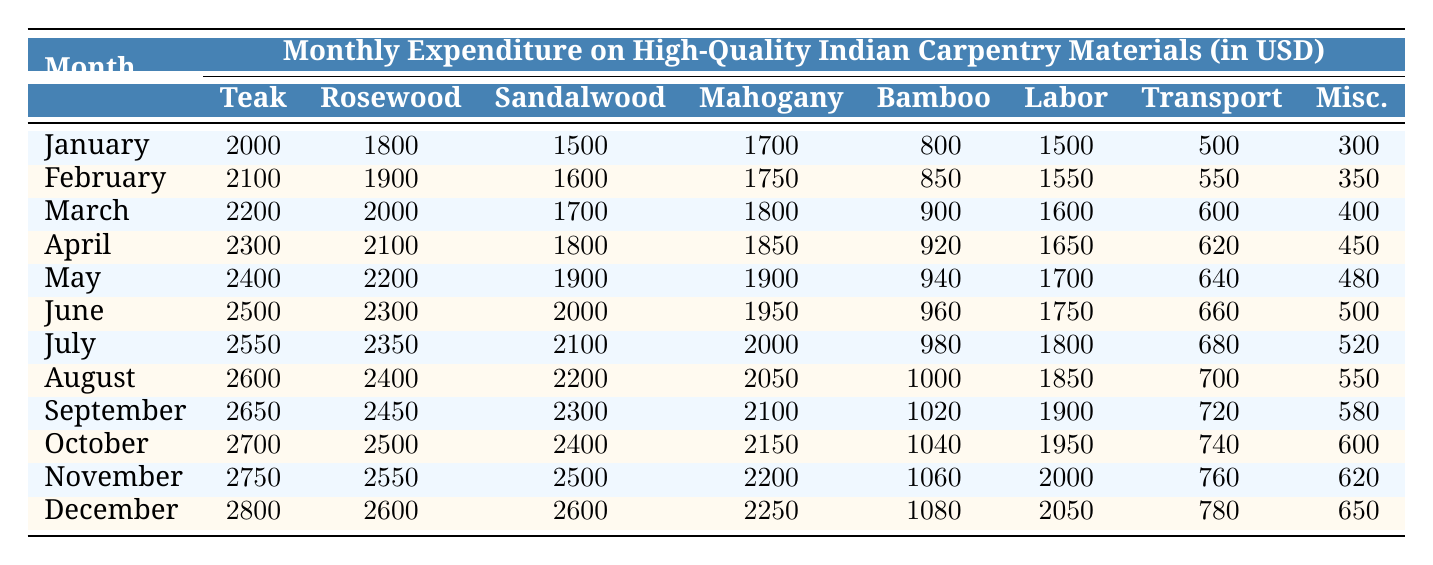What is the expenditure on Teak Wood Planks in April? The table shows that in April, the expenditure on Teak Wood Planks is listed directly under the corresponding month. Therefore, it can be read straight from the table.
Answer: 2300 Which month had the highest Labor Costs? By examining the Labor Costs row for each month, November shows the highest value at 2000. This is determined by comparing all the values in the Labor Costs column.
Answer: 2000 What is the total expenditure on Rosewood for the first half of the year (January to June)? To calculate the total expenditure on Rosewood for the months January through June, we add the values: 1800 + 1900 + 2000 + 2100 + 2200 + 2300 = 12600. This is done by summing up the individual monthly expenditures from the table.
Answer: 12600 Did the expenditure on BambooSheets increase every month throughout the year? By analyzing the BambooSheets column, we can see that the values for each month are increasing sequentially from 800 in January to 1080 in December. Therefore, the statement is true.
Answer: Yes What is the average monthly expenditure on MahoganyBoards from May to December? The MahoganyBoards values from May to December are 1900, 1950, 2000, 2050, 2100, 2150, 2200, and 2250. First, we sum these values to get: 1900 + 1950 + 2000 + 2050 + 2100 + 2150 + 2200 + 2250 = 16600. Then since there are 8 months, we divide by 8, obtaining 16600 / 8 = 2075.
Answer: 2075 What was the total expenditure for materials in December? To find the total expenditure for December, we add all the material costs for that month: 2800 (Teak) + 2600 (Rosewood) + 2600 (Sandalwood) + 2250 (Mahogany) + 1080 (Bamboo) + 2050 (Labor) + 780 (Transportation) + 650 (Miscellaneous) = 13110. This sums each individual material cost provided for December.
Answer: 13110 